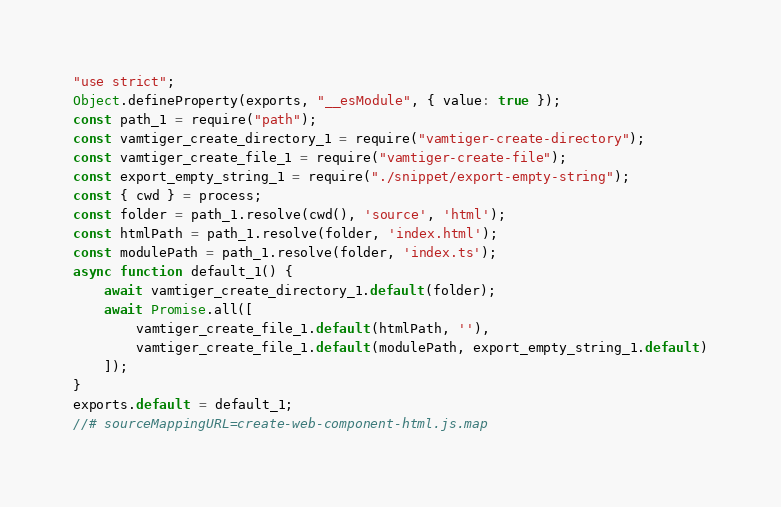Convert code to text. <code><loc_0><loc_0><loc_500><loc_500><_JavaScript_>"use strict";
Object.defineProperty(exports, "__esModule", { value: true });
const path_1 = require("path");
const vamtiger_create_directory_1 = require("vamtiger-create-directory");
const vamtiger_create_file_1 = require("vamtiger-create-file");
const export_empty_string_1 = require("./snippet/export-empty-string");
const { cwd } = process;
const folder = path_1.resolve(cwd(), 'source', 'html');
const htmlPath = path_1.resolve(folder, 'index.html');
const modulePath = path_1.resolve(folder, 'index.ts');
async function default_1() {
    await vamtiger_create_directory_1.default(folder);
    await Promise.all([
        vamtiger_create_file_1.default(htmlPath, ''),
        vamtiger_create_file_1.default(modulePath, export_empty_string_1.default)
    ]);
}
exports.default = default_1;
//# sourceMappingURL=create-web-component-html.js.map</code> 